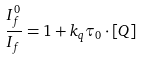<formula> <loc_0><loc_0><loc_500><loc_500>\frac { I _ { f } ^ { 0 } } { I _ { f } } = 1 + k _ { q } \tau _ { 0 } \cdot [ Q ]</formula> 